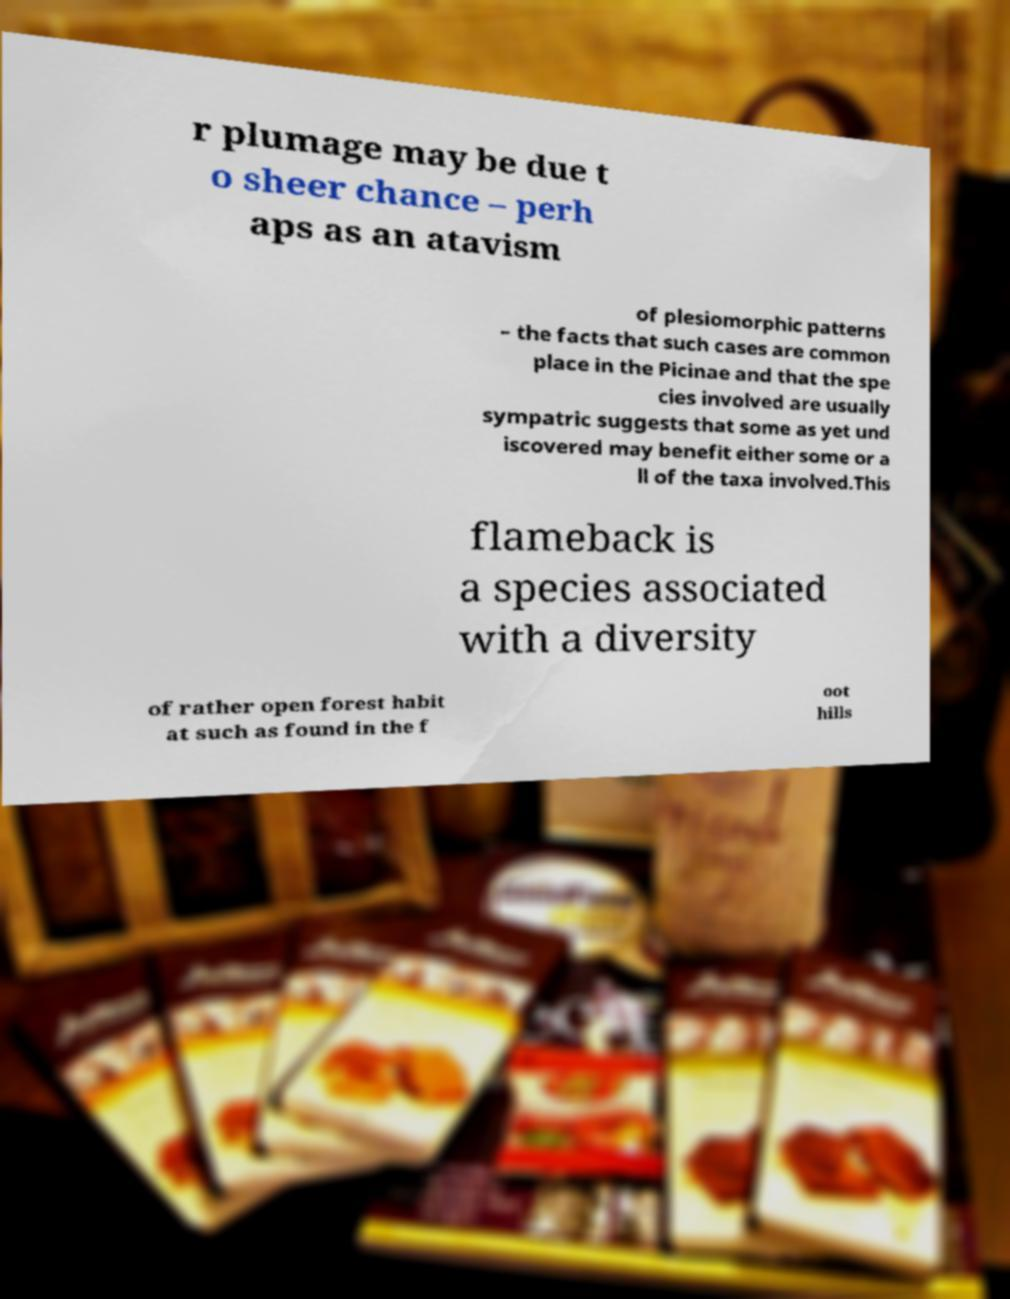For documentation purposes, I need the text within this image transcribed. Could you provide that? r plumage may be due t o sheer chance – perh aps as an atavism of plesiomorphic patterns – the facts that such cases are common place in the Picinae and that the spe cies involved are usually sympatric suggests that some as yet und iscovered may benefit either some or a ll of the taxa involved.This flameback is a species associated with a diversity of rather open forest habit at such as found in the f oot hills 